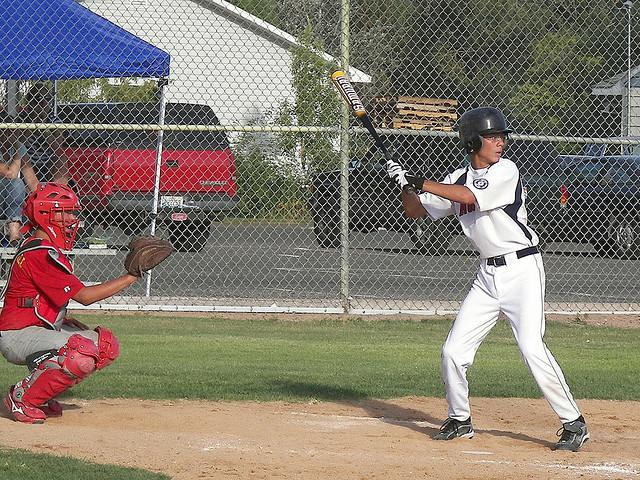Why is he holding the bat behind him? Please explain your reasoning. hit ball. The batter is getting ready to attempt to hit the ball, as is customary in baseball games. 